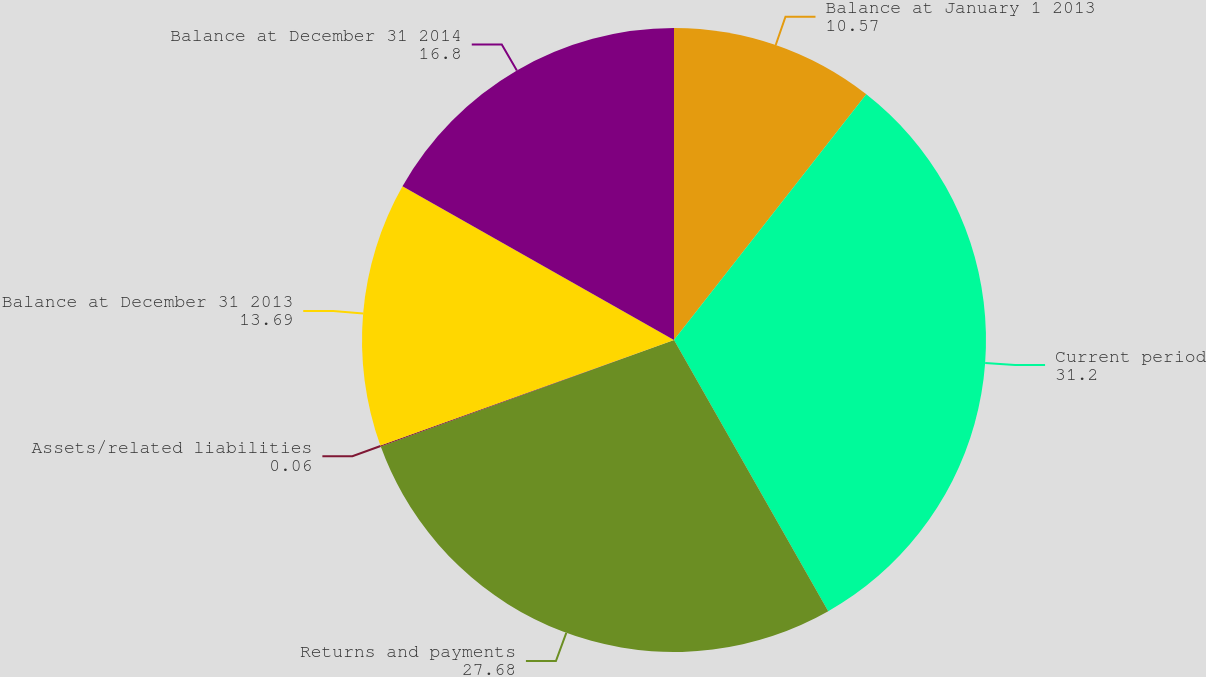Convert chart. <chart><loc_0><loc_0><loc_500><loc_500><pie_chart><fcel>Balance at January 1 2013<fcel>Current period<fcel>Returns and payments<fcel>Assets/related liabilities<fcel>Balance at December 31 2013<fcel>Balance at December 31 2014<nl><fcel>10.57%<fcel>31.2%<fcel>27.68%<fcel>0.06%<fcel>13.69%<fcel>16.8%<nl></chart> 